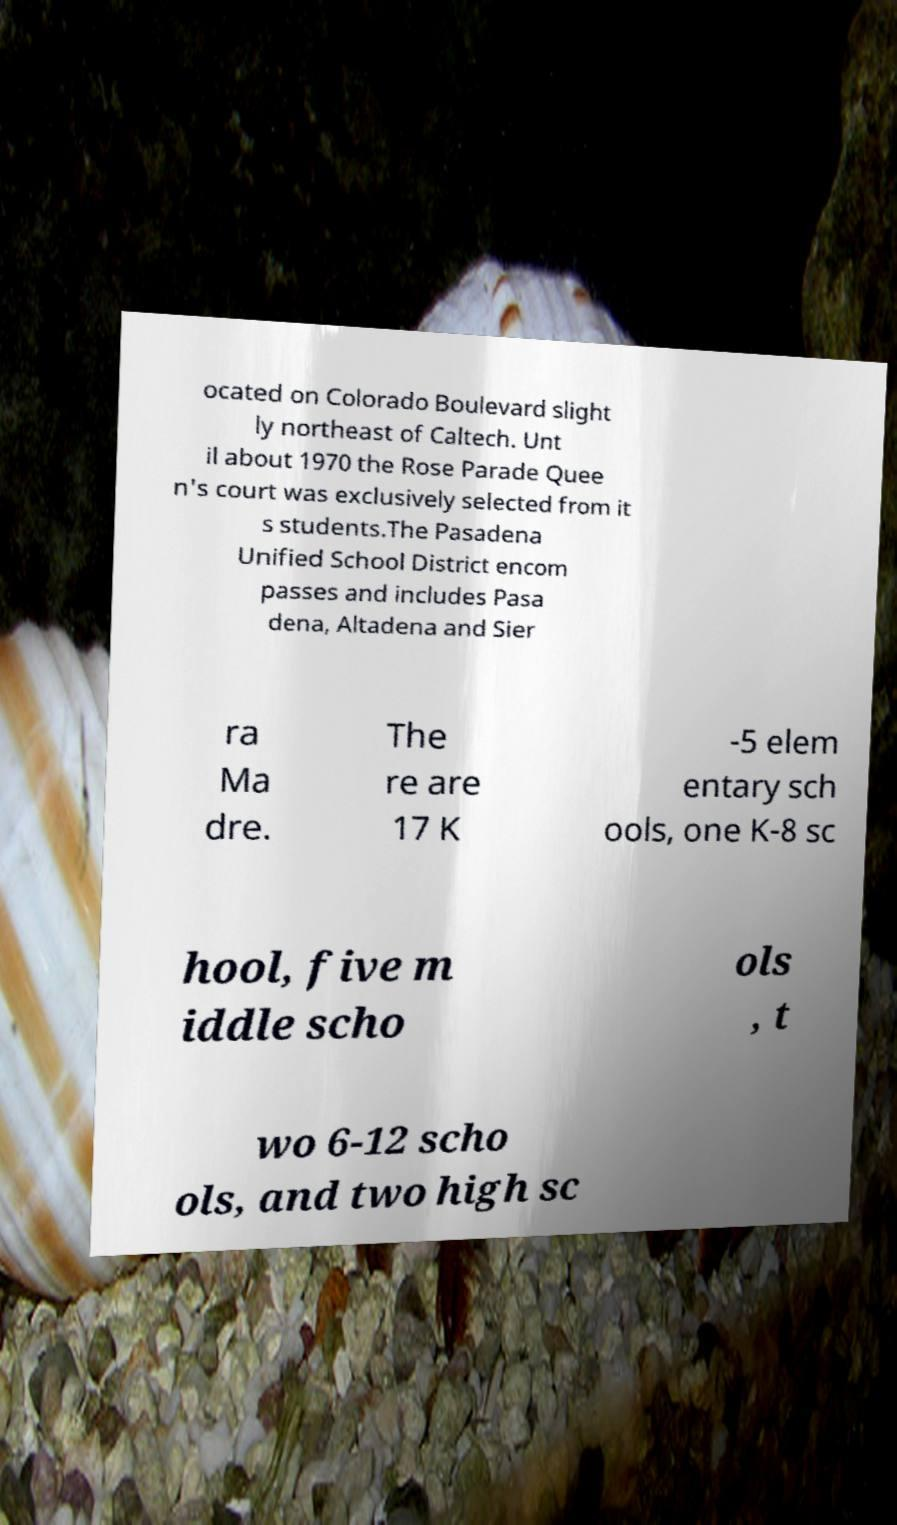For documentation purposes, I need the text within this image transcribed. Could you provide that? ocated on Colorado Boulevard slight ly northeast of Caltech. Unt il about 1970 the Rose Parade Quee n's court was exclusively selected from it s students.The Pasadena Unified School District encom passes and includes Pasa dena, Altadena and Sier ra Ma dre. The re are 17 K -5 elem entary sch ools, one K-8 sc hool, five m iddle scho ols , t wo 6-12 scho ols, and two high sc 